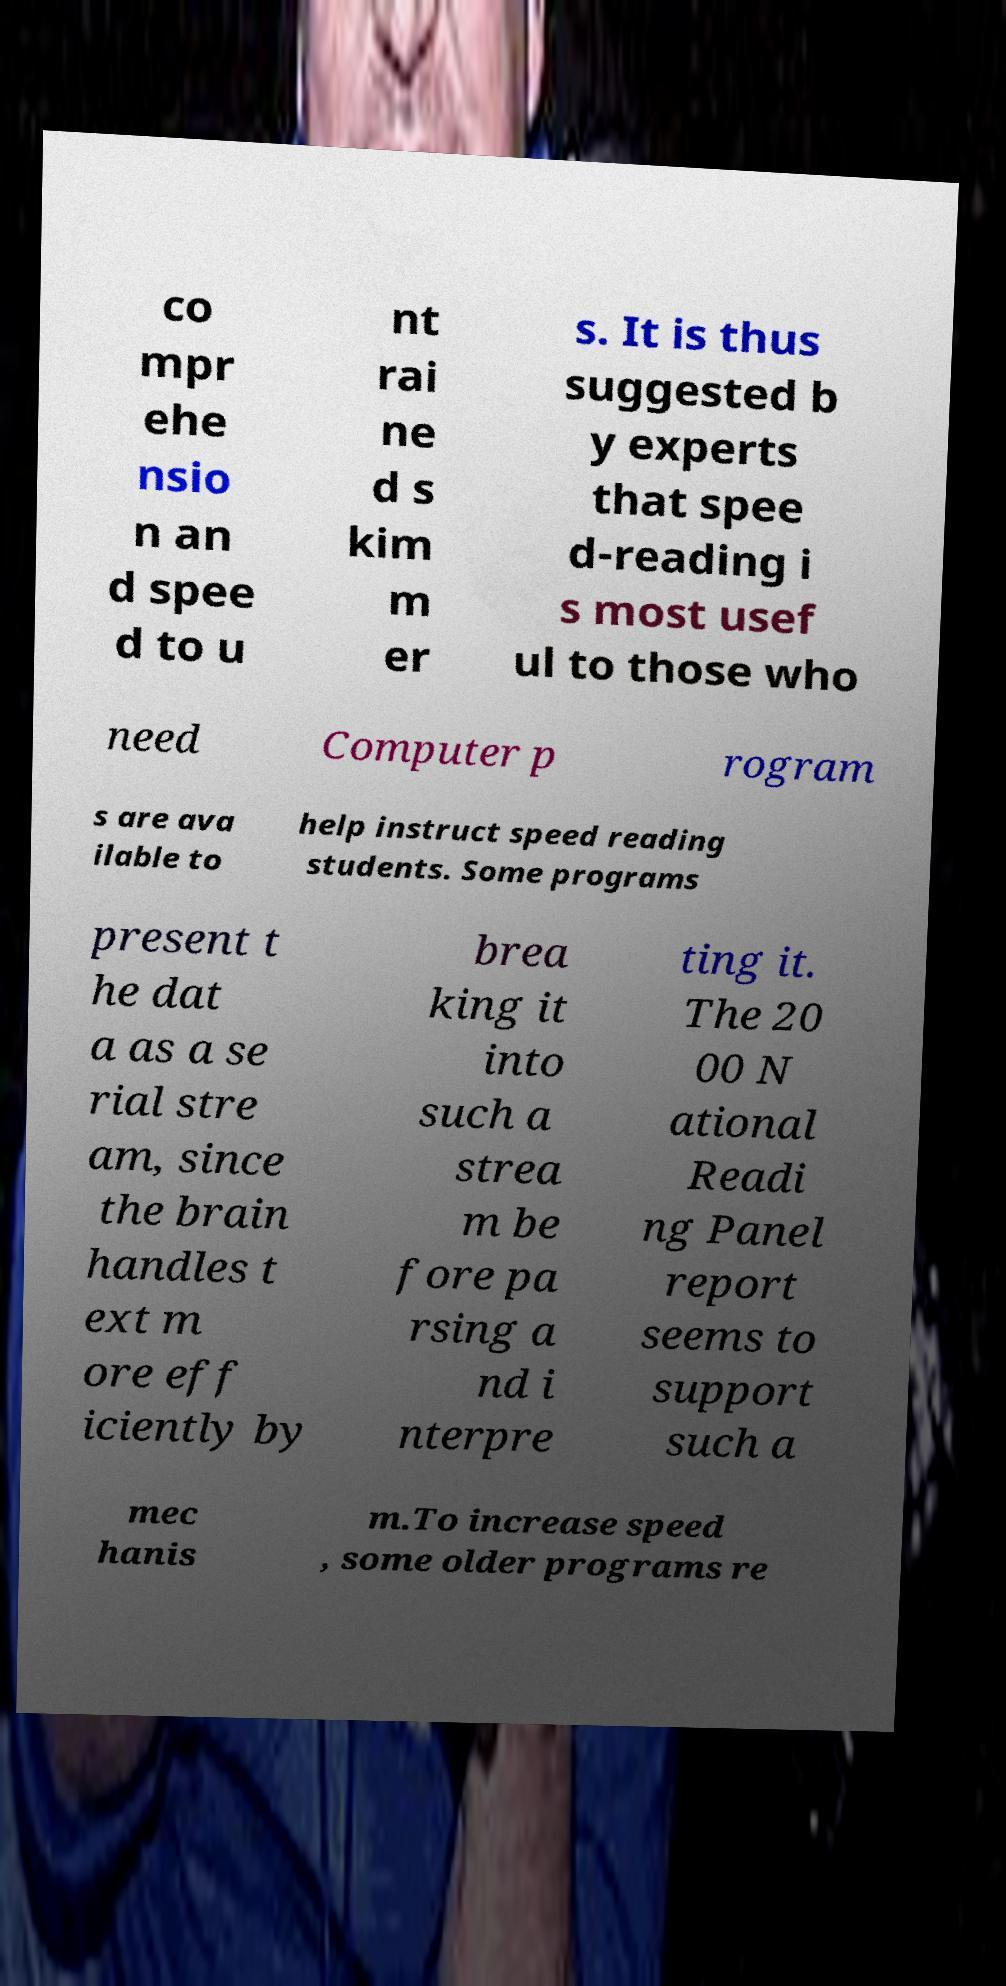Can you accurately transcribe the text from the provided image for me? co mpr ehe nsio n an d spee d to u nt rai ne d s kim m er s. It is thus suggested b y experts that spee d-reading i s most usef ul to those who need Computer p rogram s are ava ilable to help instruct speed reading students. Some programs present t he dat a as a se rial stre am, since the brain handles t ext m ore eff iciently by brea king it into such a strea m be fore pa rsing a nd i nterpre ting it. The 20 00 N ational Readi ng Panel report seems to support such a mec hanis m.To increase speed , some older programs re 